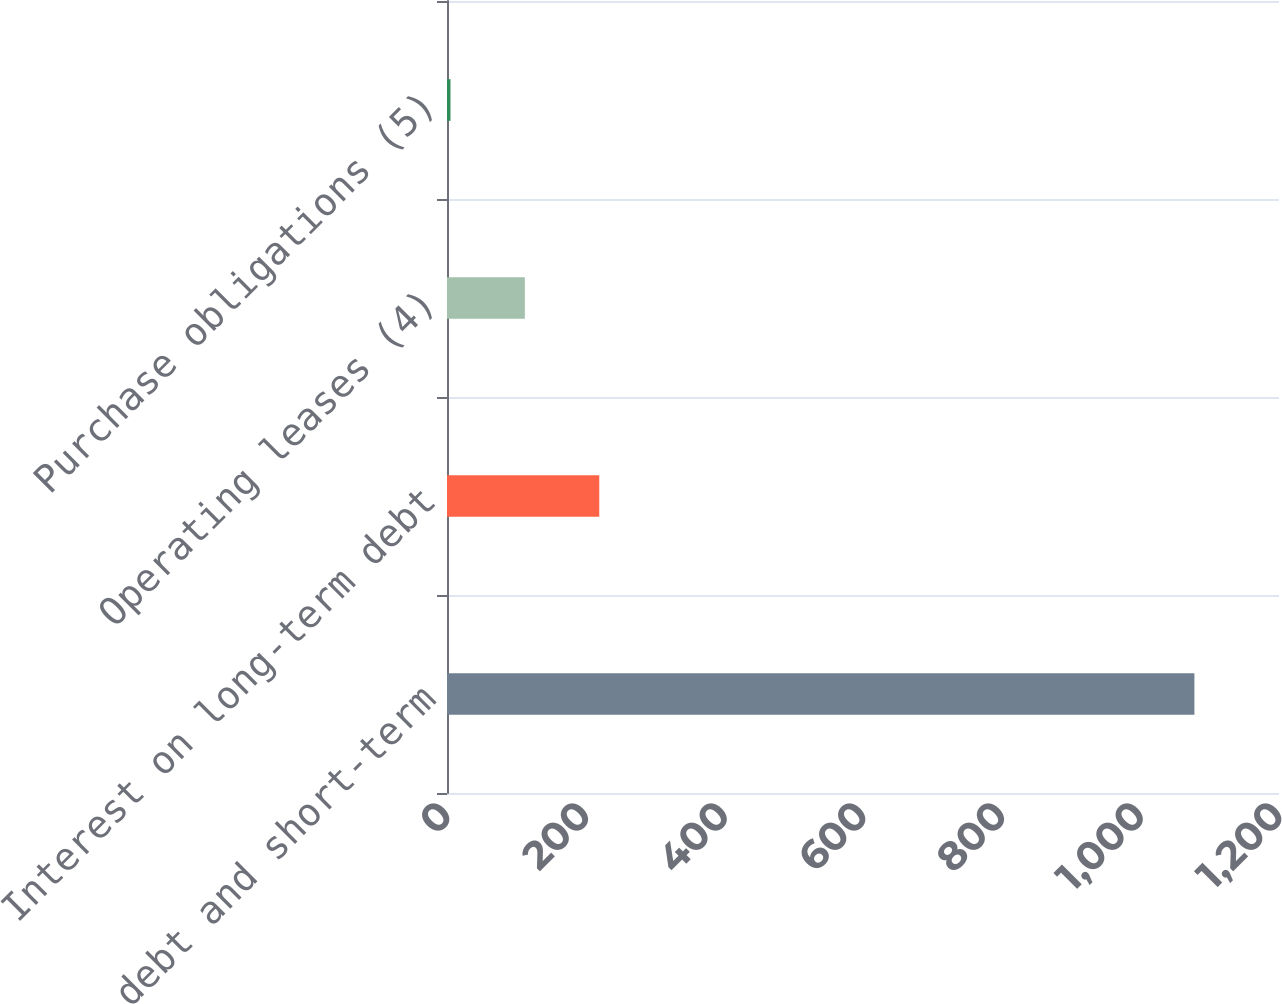Convert chart. <chart><loc_0><loc_0><loc_500><loc_500><bar_chart><fcel>Long-term debt and short-term<fcel>Interest on long-term debt<fcel>Operating leases (4)<fcel>Purchase obligations (5)<nl><fcel>1078<fcel>219.6<fcel>112.3<fcel>5<nl></chart> 